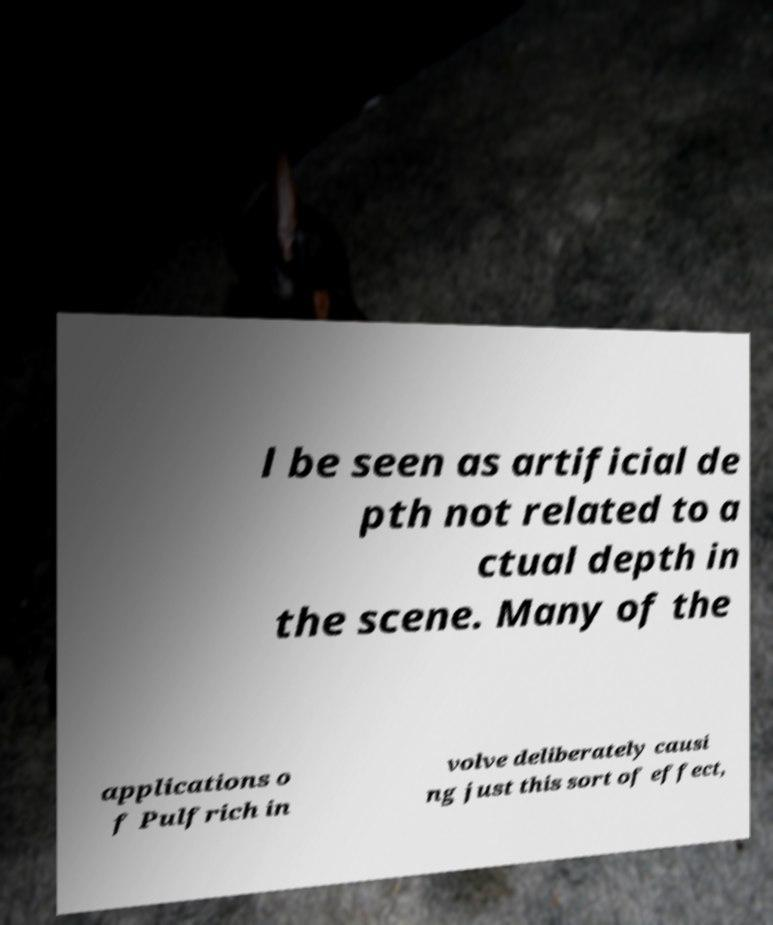Please identify and transcribe the text found in this image. l be seen as artificial de pth not related to a ctual depth in the scene. Many of the applications o f Pulfrich in volve deliberately causi ng just this sort of effect, 